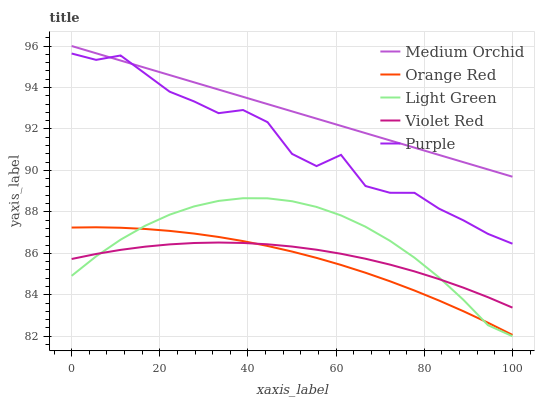Does Violet Red have the minimum area under the curve?
Answer yes or no. No. Does Violet Red have the maximum area under the curve?
Answer yes or no. No. Is Violet Red the smoothest?
Answer yes or no. No. Is Violet Red the roughest?
Answer yes or no. No. Does Violet Red have the lowest value?
Answer yes or no. No. Does Violet Red have the highest value?
Answer yes or no. No. Is Light Green less than Medium Orchid?
Answer yes or no. Yes. Is Purple greater than Light Green?
Answer yes or no. Yes. Does Light Green intersect Medium Orchid?
Answer yes or no. No. 